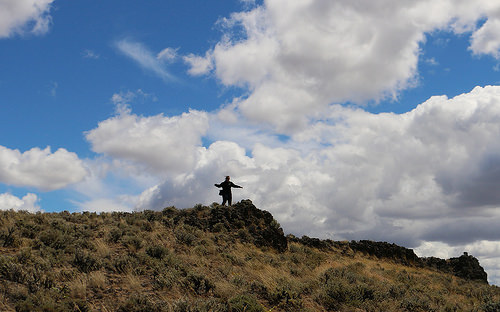<image>
Is there a atmosphere under the cloud? No. The atmosphere is not positioned under the cloud. The vertical relationship between these objects is different. Where is the clouds in relation to the mountain? Is it behind the mountain? Yes. From this viewpoint, the clouds is positioned behind the mountain, with the mountain partially or fully occluding the clouds. 